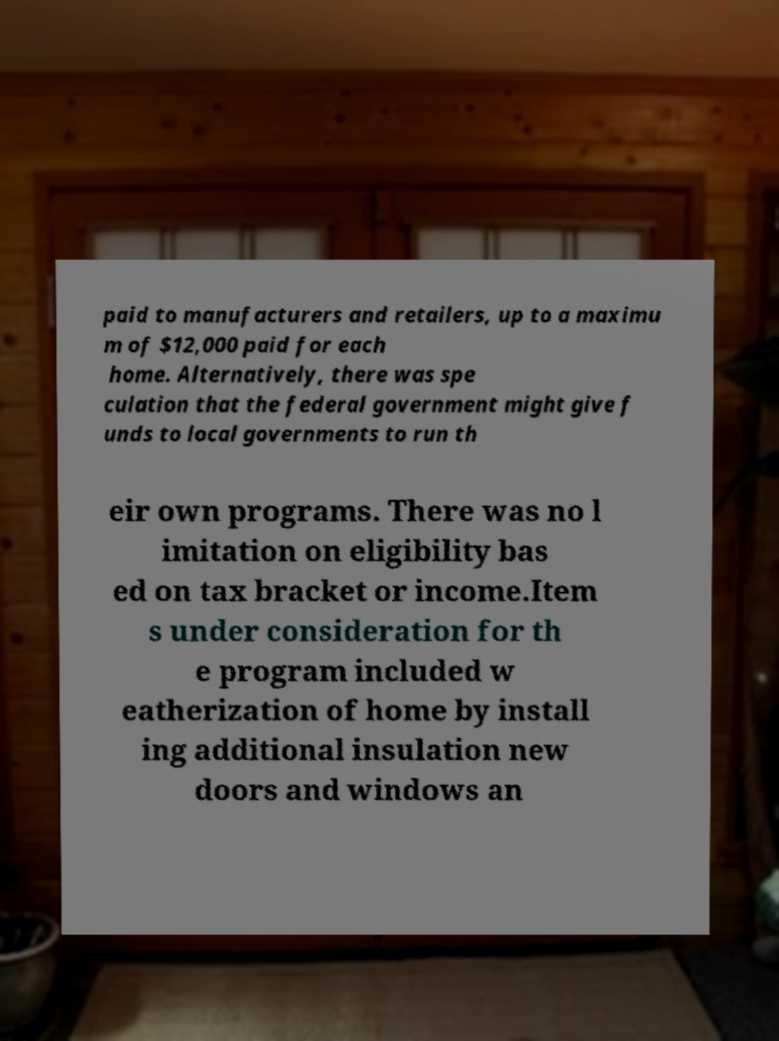Could you extract and type out the text from this image? paid to manufacturers and retailers, up to a maximu m of $12,000 paid for each home. Alternatively, there was spe culation that the federal government might give f unds to local governments to run th eir own programs. There was no l imitation on eligibility bas ed on tax bracket or income.Item s under consideration for th e program included w eatherization of home by install ing additional insulation new doors and windows an 